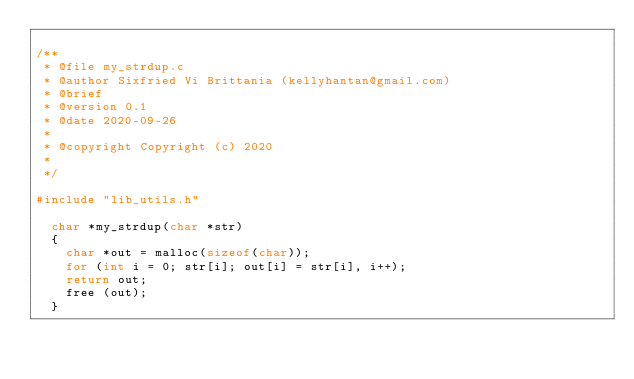Convert code to text. <code><loc_0><loc_0><loc_500><loc_500><_C_>
/**
 * @file my_strdup.c
 * @author Sixfried Vi Brittania (kellyhantan@gmail.com)
 * @brief 
 * @version 0.1
 * @date 2020-09-26
 * 
 * @copyright Copyright (c) 2020
 * 
 */

#include "lib_utils.h"

	char *my_strdup(char *str)
	{
		char *out = malloc(sizeof(char));
		for (int i = 0; str[i]; out[i] = str[i], i++);
		return out;
		free (out);
	}
</code> 